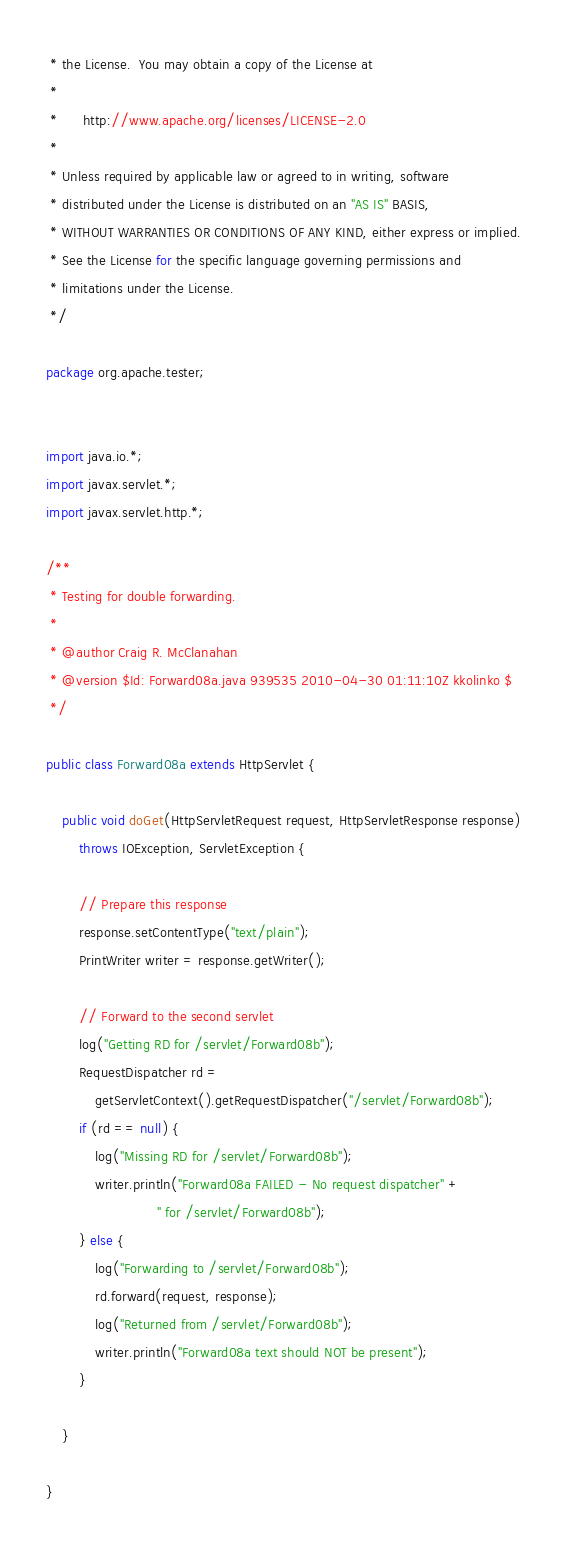Convert code to text. <code><loc_0><loc_0><loc_500><loc_500><_Java_> * the License.  You may obtain a copy of the License at
 * 
 *      http://www.apache.org/licenses/LICENSE-2.0
 * 
 * Unless required by applicable law or agreed to in writing, software
 * distributed under the License is distributed on an "AS IS" BASIS,
 * WITHOUT WARRANTIES OR CONDITIONS OF ANY KIND, either express or implied.
 * See the License for the specific language governing permissions and
 * limitations under the License.
 */

package org.apache.tester;


import java.io.*;
import javax.servlet.*;
import javax.servlet.http.*;

/**
 * Testing for double forwarding.
 *
 * @author Craig R. McClanahan
 * @version $Id: Forward08a.java 939535 2010-04-30 01:11:10Z kkolinko $
 */

public class Forward08a extends HttpServlet {

    public void doGet(HttpServletRequest request, HttpServletResponse response)
        throws IOException, ServletException {

        // Prepare this response
        response.setContentType("text/plain");
        PrintWriter writer = response.getWriter();

        // Forward to the second servlet
        log("Getting RD for /servlet/Forward08b");
        RequestDispatcher rd =
            getServletContext().getRequestDispatcher("/servlet/Forward08b");
        if (rd == null) {
            log("Missing RD for /servlet/Forward08b");
            writer.println("Forward08a FAILED - No request dispatcher" +
                           " for /servlet/Forward08b");
        } else {
            log("Forwarding to /servlet/Forward08b");
            rd.forward(request, response);
            log("Returned from /servlet/Forward08b");
            writer.println("Forward08a text should NOT be present");
        }

    }

}
</code> 